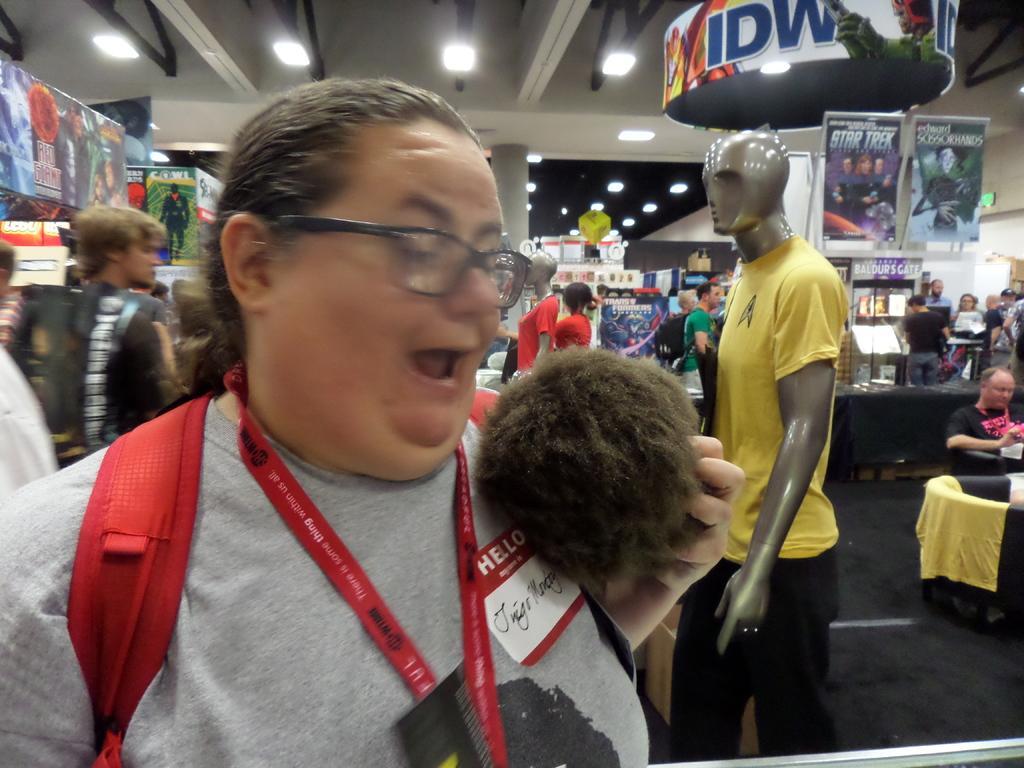Please provide a concise description of this image. This picture shows an inner view of a store. we see few people standing and see couple of mannequins with clothes and we see a man seated and we see few advertisement hoardings and lights to the ceiling and we see a woman wore spectacles and a backpack on the back and a id card and we see few posts. 